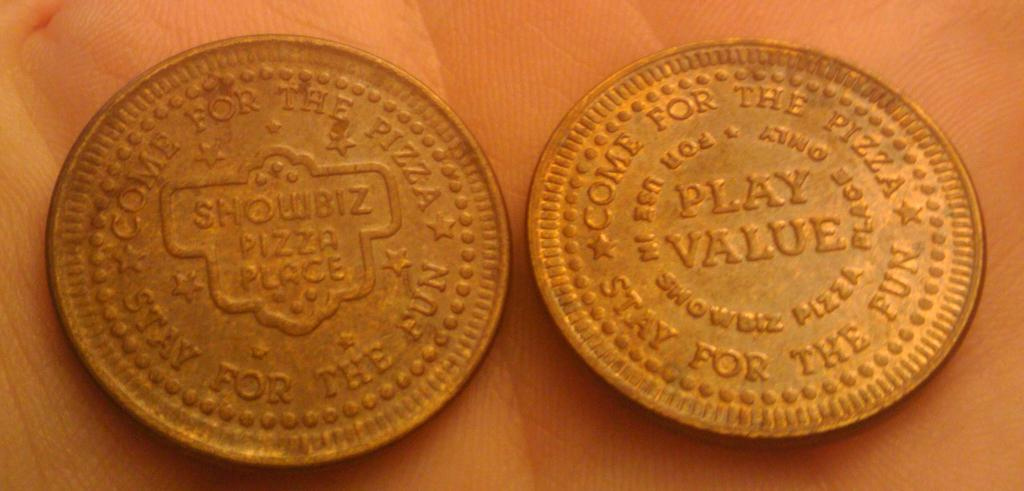<image>
Give a short and clear explanation of the subsequent image. Two gold coin with engraving that says Showbiz Pizza Place. 